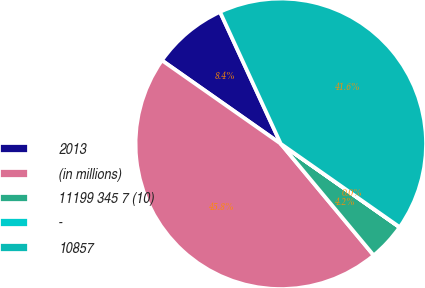Convert chart. <chart><loc_0><loc_0><loc_500><loc_500><pie_chart><fcel>2013<fcel>(in millions)<fcel>11199 345 7 (10)<fcel>-<fcel>10857<nl><fcel>8.39%<fcel>45.79%<fcel>4.2%<fcel>0.02%<fcel>41.6%<nl></chart> 